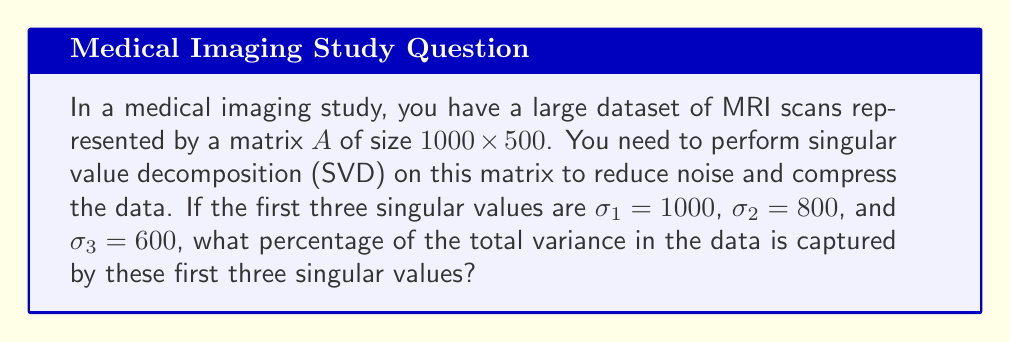Could you help me with this problem? To solve this problem, we'll follow these steps:

1) The singular value decomposition of matrix $A$ is given by:

   $A = U\Sigma V^T$

   where $\Sigma$ is a diagonal matrix containing the singular values.

2) The total variance in the data is equal to the sum of squares of all singular values:

   $\text{Total Variance} = \sum_{i=1}^{\min(m,n)} \sigma_i^2$

   where $m$ and $n$ are the dimensions of $A$, and $\sigma_i$ are the singular values.

3) The variance captured by the first $k$ singular values is:

   $\text{Captured Variance} = \sum_{i=1}^k \sigma_i^2$

4) In this case, we're interested in the first three singular values:

   $\text{Captured Variance} = \sigma_1^2 + \sigma_2^2 + \sigma_3^2$
                              $= 1000^2 + 800^2 + 600^2$
                              $= 1,000,000 + 640,000 + 360,000$
                              $= 2,000,000$

5) To calculate the percentage, we need the total variance. However, we don't have all singular values. But we know that singular values are typically ordered in descending order, so these first three are the largest.

6) We can estimate the percentage as:

   $\text{Percentage} = \frac{\text{Captured Variance}}{\text{Total Variance}} \times 100\%$
                      $\approx \frac{2,000,000}{\text{Total Variance}} \times 100\%$

7) This percentage will be an upper bound of the actual percentage, as the denominator (Total Variance) is larger than 2,000,000.

8) Without more information, we can't calculate the exact percentage, but we can say it's less than or equal to 100%.
Answer: $\leq 100\%$ 